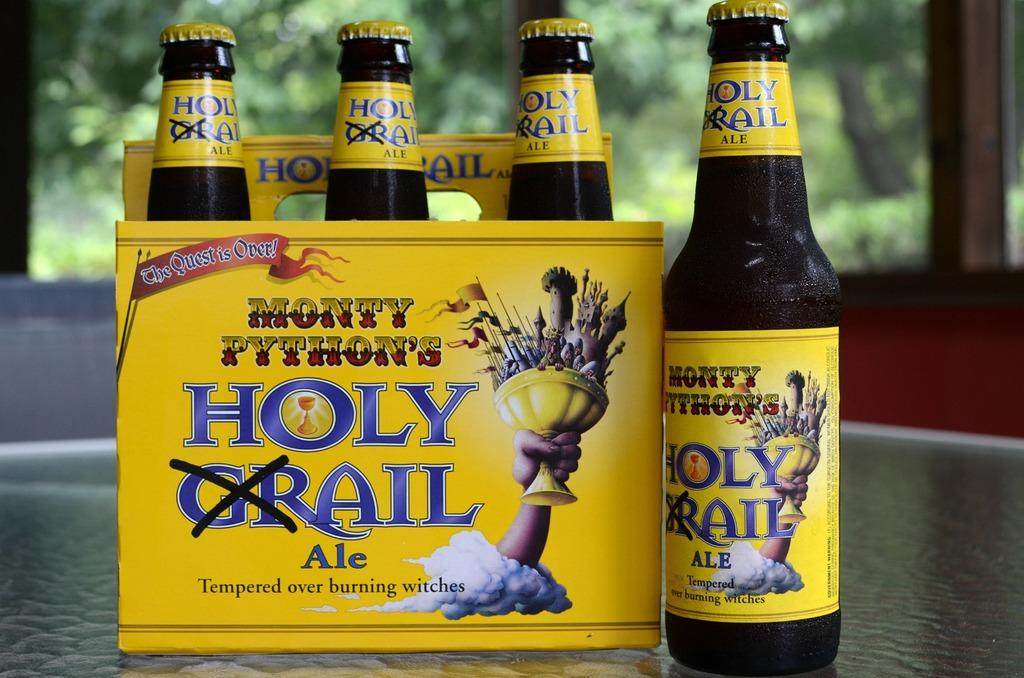<image>
Create a compact narrative representing the image presented. Four bottles of Holy Grail Ale with the GR crossed out. 